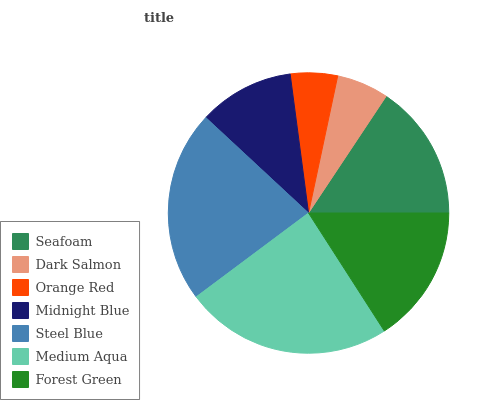Is Orange Red the minimum?
Answer yes or no. Yes. Is Medium Aqua the maximum?
Answer yes or no. Yes. Is Dark Salmon the minimum?
Answer yes or no. No. Is Dark Salmon the maximum?
Answer yes or no. No. Is Seafoam greater than Dark Salmon?
Answer yes or no. Yes. Is Dark Salmon less than Seafoam?
Answer yes or no. Yes. Is Dark Salmon greater than Seafoam?
Answer yes or no. No. Is Seafoam less than Dark Salmon?
Answer yes or no. No. Is Seafoam the high median?
Answer yes or no. Yes. Is Seafoam the low median?
Answer yes or no. Yes. Is Steel Blue the high median?
Answer yes or no. No. Is Steel Blue the low median?
Answer yes or no. No. 